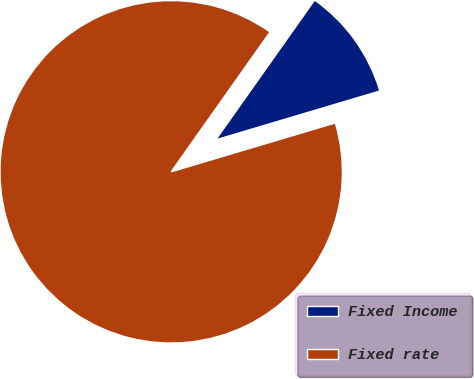Convert chart. <chart><loc_0><loc_0><loc_500><loc_500><pie_chart><fcel>Fixed Income<fcel>Fixed rate<nl><fcel>10.6%<fcel>89.4%<nl></chart> 